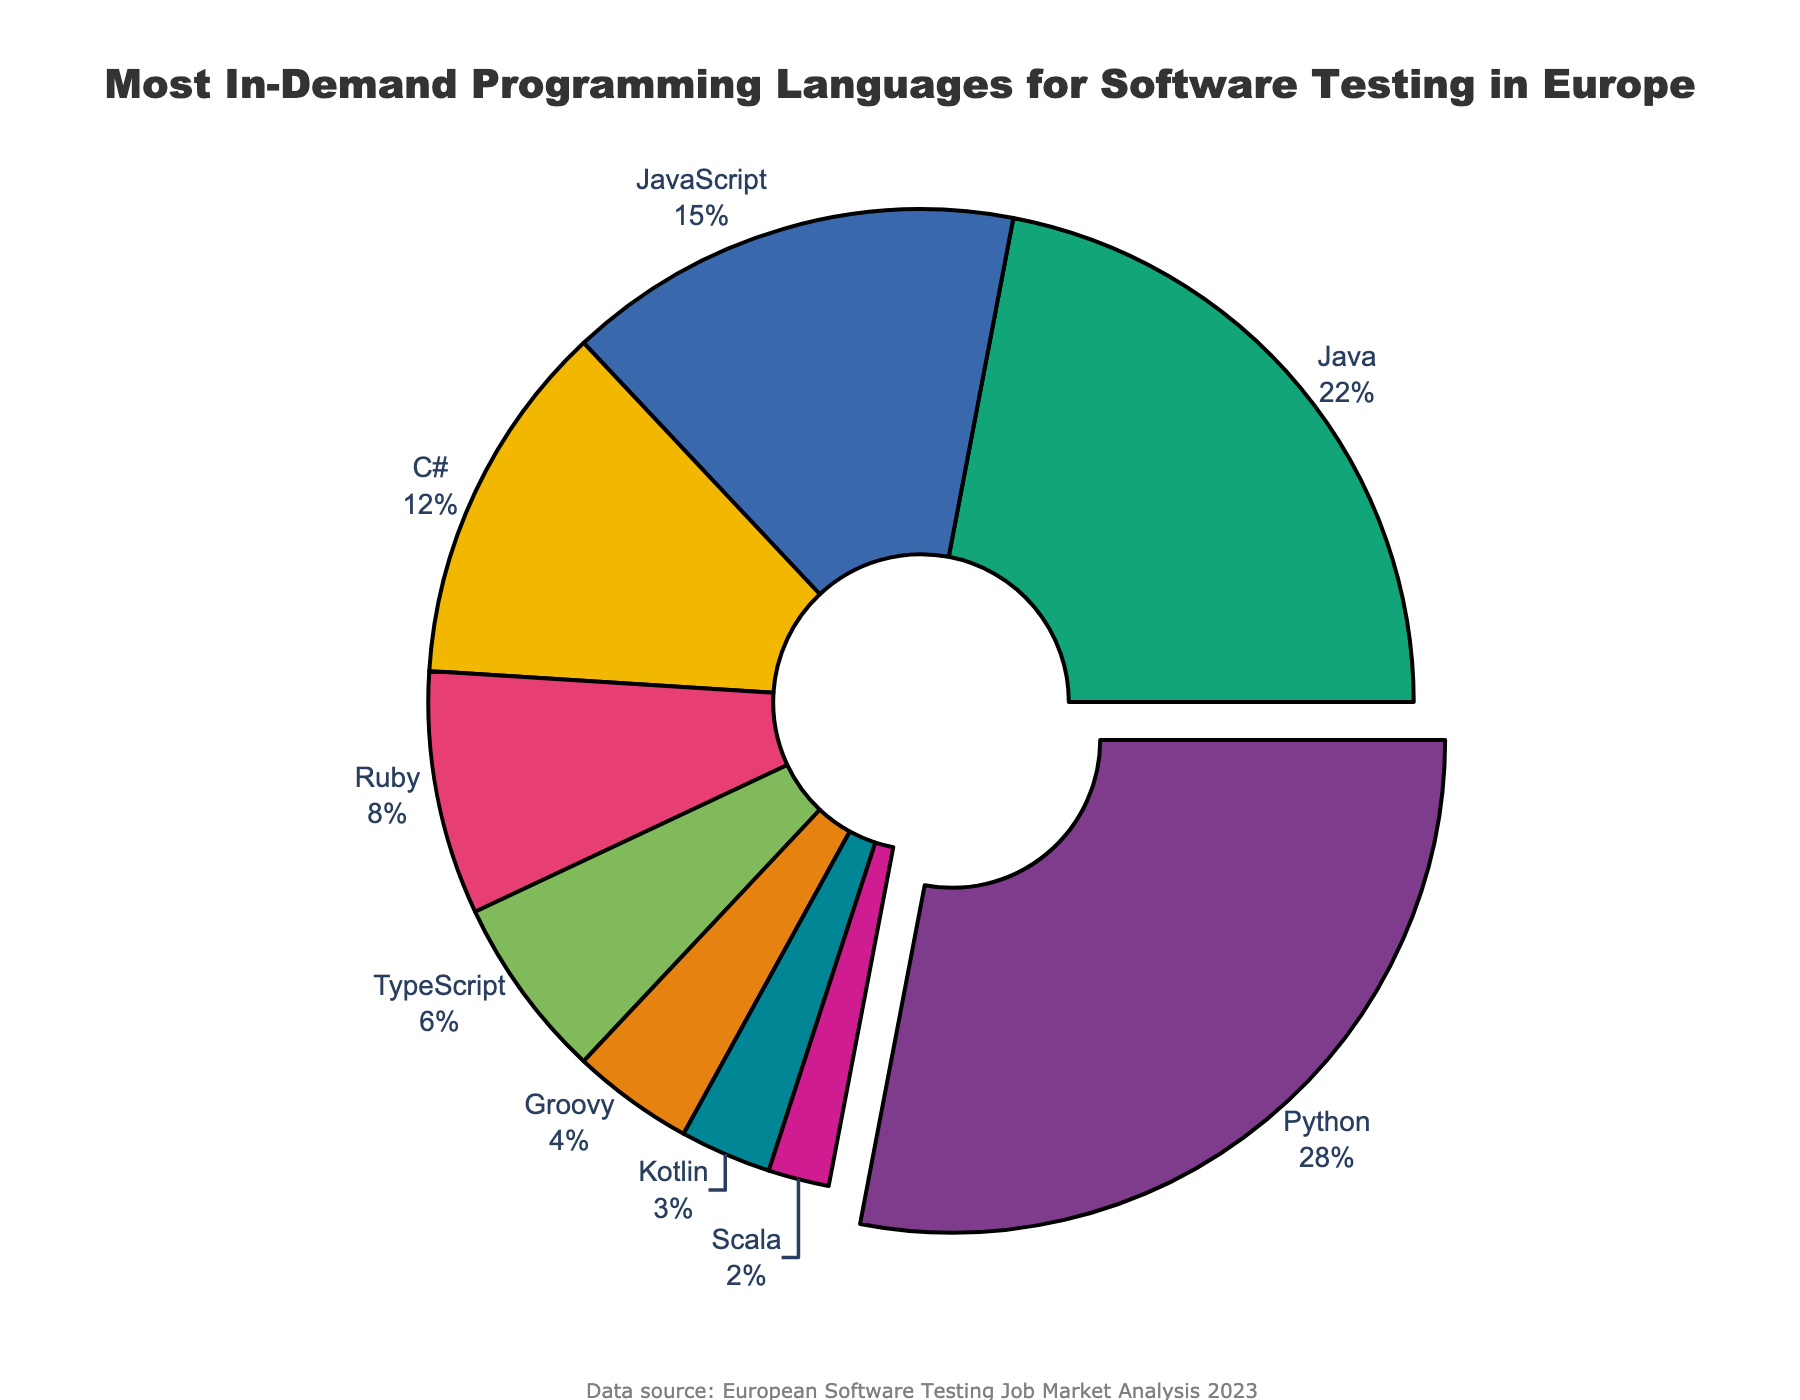What percentage of software testing roles in Europe require Python and Java combined? To find the combined percentage, we sum the percentages for Python (28%) and Java (22%). Thus, 28 + 22 = 50.
Answer: 50% Which programming language is the least in demand for software testing roles in Europe? By looking at the chart, Scala has the smallest slice and is listed with 2%.
Answer: Scala What is the difference in demand between JavaScript and C#? JavaScript has a percentage of 15%, and C# has 12%. The difference is 15 - 12 = 3.
Answer: 3% How many languages have a demand percentage of 10% or higher? From the plot, Python (28%), Java (22%), JavaScript (15%), and C# (12%) all have percentages over 10%. Therefore, there are 4 languages.
Answer: 4 Among the languages with more than 5% demand, which one is closest in demand to Ruby? Ruby has 8%, and the only language slightly higher than Ruby above 5% is C# with 12%.
Answer: C# What is the combined percentage of TypeScript, Groovy, and Kotlin? Adding the percentages of TypeScript (6%), Groovy (4%), and Kotlin (3%) gives 6 + 4 + 3 = 13.
Answer: 13% Which language is most visually noticeable in the pie chart and why? Python is the most noticeable because it has the largest slice (28%) and is also pulled out slightly from the rest of the pie.
Answer: Python Does TypeScript have more or less demand than Groovy and Scala combined? TypeScript has 6%, Groovy and Scala combined is 4 + 2 = 6%. Both are equal.
Answer: Equal What percentage of the least in-demand languages combined would make up a quarter of the pie? The total percentages contributed by less-demand languages: Ruby (8%) + TypeScript (6%) + Groovy (4%) + Kotlin (3%) + Scala (2%) = 8 + 6 + 4 + 3 + 2 = 23, which is close to but not quite 25%.
Answer: 23% How much higher is the demand for Java compared to Kotlin? Java has 22% and Kotlin has 3%. The difference is 22 - 3 = 19.
Answer: 19 